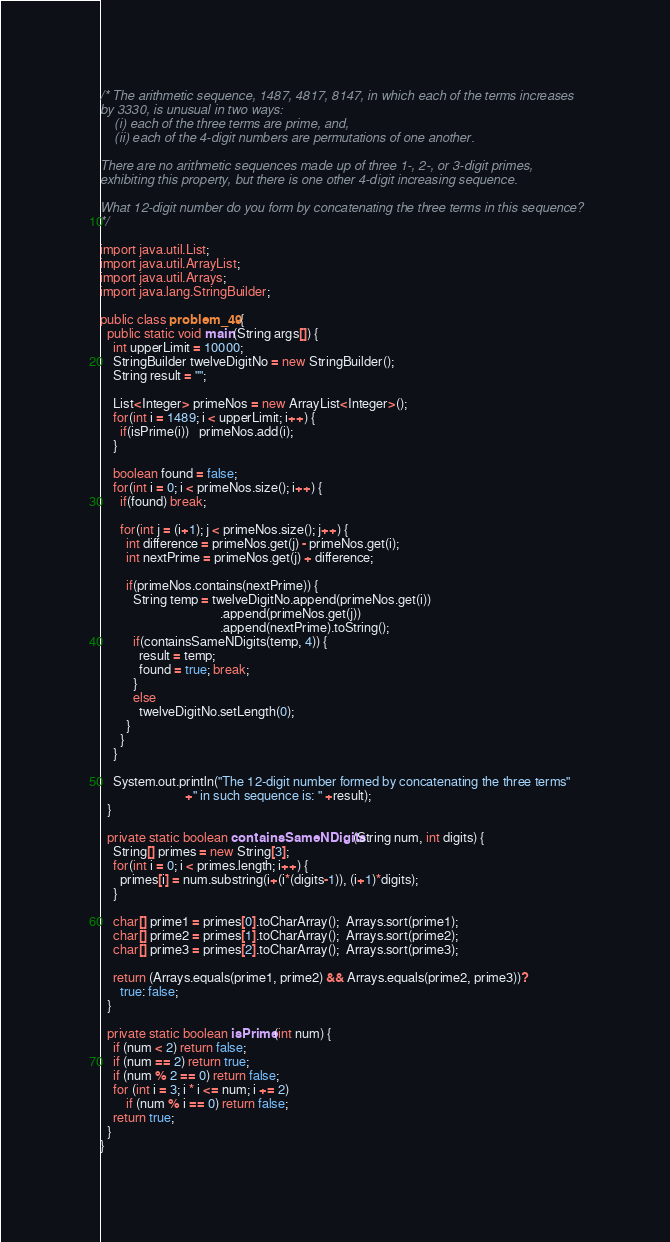<code> <loc_0><loc_0><loc_500><loc_500><_Java_>/* The arithmetic sequence, 1487, 4817, 8147, in which each of the terms increases
by 3330, is unusual in two ways:
    (i) each of the three terms are prime, and,
    (ii) each of the 4-digit numbers are permutations of one another.

There are no arithmetic sequences made up of three 1-, 2-, or 3-digit primes,
exhibiting this property, but there is one other 4-digit increasing sequence.

What 12-digit number do you form by concatenating the three terms in this sequence?
*/

import java.util.List;
import java.util.ArrayList;
import java.util.Arrays;
import java.lang.StringBuilder;

public class problem_49 {
  public static void main(String args[]) {
    int upperLimit = 10000;
    StringBuilder twelveDigitNo = new StringBuilder();
    String result = "";

    List<Integer> primeNos = new ArrayList<Integer>();
    for(int i = 1489; i < upperLimit; i++) {
      if(isPrime(i))   primeNos.add(i);
    }

    boolean found = false;
    for(int i = 0; i < primeNos.size(); i++) {
      if(found) break;

      for(int j = (i+1); j < primeNos.size(); j++) {
        int difference = primeNos.get(j) - primeNos.get(i);
        int nextPrime = primeNos.get(j) + difference;

        if(primeNos.contains(nextPrime)) {
          String temp = twelveDigitNo.append(primeNos.get(i))
                                     .append(primeNos.get(j))
                                     .append(nextPrime).toString();
          if(containsSameNDigits(temp, 4)) {
            result = temp;
            found = true; break;
          }
          else
            twelveDigitNo.setLength(0);
        }
      }
    }

    System.out.println("The 12-digit number formed by concatenating the three terms"
                          +" in such sequence is: " +result);
  }

  private static boolean containsSameNDigits(String num, int digits) {
    String[] primes = new String[3];
    for(int i = 0; i < primes.length; i++) {
      primes[i] = num.substring(i+(i*(digits-1)), (i+1)*digits);
    }

    char[] prime1 = primes[0].toCharArray();  Arrays.sort(prime1);
    char[] prime2 = primes[1].toCharArray();  Arrays.sort(prime2);
    char[] prime3 = primes[2].toCharArray();  Arrays.sort(prime3);

    return (Arrays.equals(prime1, prime2) && Arrays.equals(prime2, prime3))?
      true: false;
  }

  private static boolean isPrime(int num) {
    if (num < 2) return false;
    if (num == 2) return true;
    if (num % 2 == 0) return false;
    for (int i = 3; i * i <= num; i += 2)
        if (num % i == 0) return false;
    return true;
  }
}</code> 